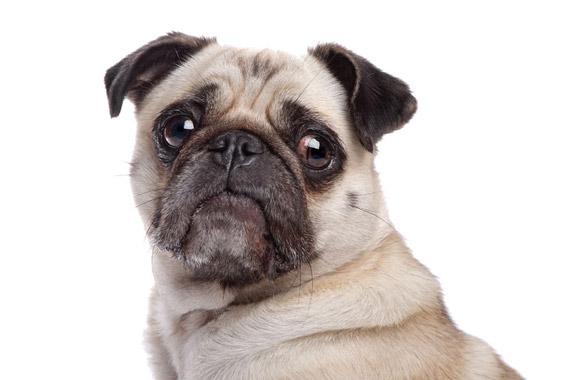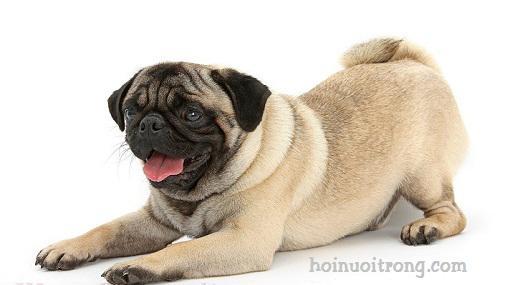The first image is the image on the left, the second image is the image on the right. Analyze the images presented: Is the assertion "In total, two pug tails are visible." valid? Answer yes or no. No. 